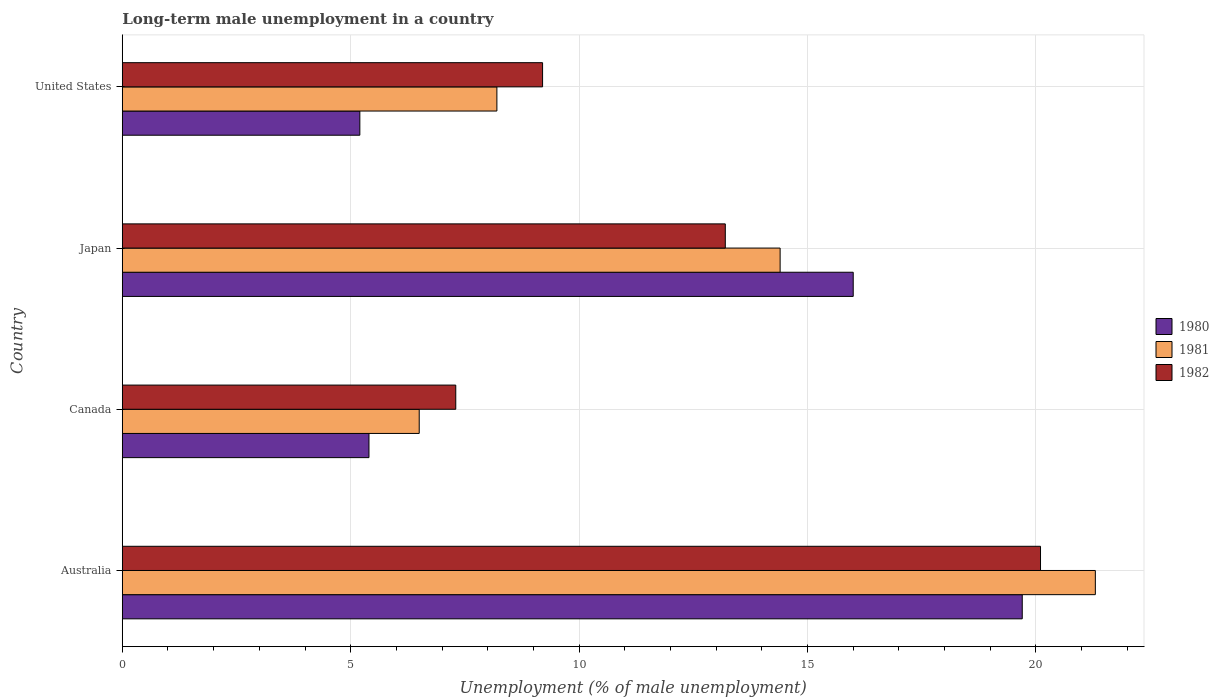How many bars are there on the 1st tick from the top?
Ensure brevity in your answer.  3. In how many cases, is the number of bars for a given country not equal to the number of legend labels?
Offer a terse response. 0. What is the percentage of long-term unemployed male population in 1980 in Australia?
Ensure brevity in your answer.  19.7. Across all countries, what is the maximum percentage of long-term unemployed male population in 1982?
Your answer should be compact. 20.1. Across all countries, what is the minimum percentage of long-term unemployed male population in 1982?
Your answer should be compact. 7.3. In which country was the percentage of long-term unemployed male population in 1980 maximum?
Provide a short and direct response. Australia. In which country was the percentage of long-term unemployed male population in 1980 minimum?
Provide a succinct answer. United States. What is the total percentage of long-term unemployed male population in 1981 in the graph?
Provide a short and direct response. 50.4. What is the difference between the percentage of long-term unemployed male population in 1981 in Australia and that in Canada?
Provide a short and direct response. 14.8. What is the difference between the percentage of long-term unemployed male population in 1980 in Japan and the percentage of long-term unemployed male population in 1981 in United States?
Your answer should be compact. 7.8. What is the average percentage of long-term unemployed male population in 1981 per country?
Your answer should be compact. 12.6. What is the difference between the percentage of long-term unemployed male population in 1982 and percentage of long-term unemployed male population in 1980 in Australia?
Offer a terse response. 0.4. In how many countries, is the percentage of long-term unemployed male population in 1982 greater than 16 %?
Your answer should be very brief. 1. What is the ratio of the percentage of long-term unemployed male population in 1981 in Japan to that in United States?
Provide a succinct answer. 1.76. Is the difference between the percentage of long-term unemployed male population in 1982 in Australia and Canada greater than the difference between the percentage of long-term unemployed male population in 1980 in Australia and Canada?
Offer a very short reply. No. What is the difference between the highest and the second highest percentage of long-term unemployed male population in 1981?
Your answer should be compact. 6.9. What is the difference between the highest and the lowest percentage of long-term unemployed male population in 1981?
Your response must be concise. 14.8. How many bars are there?
Give a very brief answer. 12. What is the difference between two consecutive major ticks on the X-axis?
Offer a terse response. 5. Are the values on the major ticks of X-axis written in scientific E-notation?
Your response must be concise. No. Does the graph contain any zero values?
Provide a short and direct response. No. What is the title of the graph?
Provide a succinct answer. Long-term male unemployment in a country. What is the label or title of the X-axis?
Keep it short and to the point. Unemployment (% of male unemployment). What is the label or title of the Y-axis?
Provide a succinct answer. Country. What is the Unemployment (% of male unemployment) in 1980 in Australia?
Provide a succinct answer. 19.7. What is the Unemployment (% of male unemployment) in 1981 in Australia?
Your response must be concise. 21.3. What is the Unemployment (% of male unemployment) of 1982 in Australia?
Make the answer very short. 20.1. What is the Unemployment (% of male unemployment) in 1980 in Canada?
Make the answer very short. 5.4. What is the Unemployment (% of male unemployment) of 1982 in Canada?
Keep it short and to the point. 7.3. What is the Unemployment (% of male unemployment) in 1981 in Japan?
Your answer should be compact. 14.4. What is the Unemployment (% of male unemployment) in 1982 in Japan?
Offer a terse response. 13.2. What is the Unemployment (% of male unemployment) of 1980 in United States?
Your answer should be very brief. 5.2. What is the Unemployment (% of male unemployment) in 1981 in United States?
Your response must be concise. 8.2. What is the Unemployment (% of male unemployment) in 1982 in United States?
Give a very brief answer. 9.2. Across all countries, what is the maximum Unemployment (% of male unemployment) of 1980?
Make the answer very short. 19.7. Across all countries, what is the maximum Unemployment (% of male unemployment) in 1981?
Offer a terse response. 21.3. Across all countries, what is the maximum Unemployment (% of male unemployment) in 1982?
Your response must be concise. 20.1. Across all countries, what is the minimum Unemployment (% of male unemployment) of 1980?
Provide a succinct answer. 5.2. Across all countries, what is the minimum Unemployment (% of male unemployment) of 1982?
Your answer should be very brief. 7.3. What is the total Unemployment (% of male unemployment) in 1980 in the graph?
Make the answer very short. 46.3. What is the total Unemployment (% of male unemployment) in 1981 in the graph?
Provide a succinct answer. 50.4. What is the total Unemployment (% of male unemployment) of 1982 in the graph?
Your answer should be compact. 49.8. What is the difference between the Unemployment (% of male unemployment) in 1980 in Australia and that in Canada?
Provide a short and direct response. 14.3. What is the difference between the Unemployment (% of male unemployment) of 1981 in Australia and that in Canada?
Give a very brief answer. 14.8. What is the difference between the Unemployment (% of male unemployment) in 1980 in Australia and that in Japan?
Offer a very short reply. 3.7. What is the difference between the Unemployment (% of male unemployment) of 1982 in Australia and that in United States?
Provide a short and direct response. 10.9. What is the difference between the Unemployment (% of male unemployment) in 1982 in Canada and that in United States?
Keep it short and to the point. -1.9. What is the difference between the Unemployment (% of male unemployment) in 1980 in Japan and that in United States?
Ensure brevity in your answer.  10.8. What is the difference between the Unemployment (% of male unemployment) in 1981 in Japan and that in United States?
Provide a short and direct response. 6.2. What is the difference between the Unemployment (% of male unemployment) of 1982 in Japan and that in United States?
Your response must be concise. 4. What is the difference between the Unemployment (% of male unemployment) of 1980 in Australia and the Unemployment (% of male unemployment) of 1981 in Canada?
Your answer should be very brief. 13.2. What is the difference between the Unemployment (% of male unemployment) in 1980 in Australia and the Unemployment (% of male unemployment) in 1981 in Japan?
Your answer should be very brief. 5.3. What is the difference between the Unemployment (% of male unemployment) in 1981 in Australia and the Unemployment (% of male unemployment) in 1982 in United States?
Keep it short and to the point. 12.1. What is the difference between the Unemployment (% of male unemployment) in 1980 in Canada and the Unemployment (% of male unemployment) in 1982 in Japan?
Your answer should be compact. -7.8. What is the difference between the Unemployment (% of male unemployment) of 1981 in Canada and the Unemployment (% of male unemployment) of 1982 in Japan?
Your answer should be very brief. -6.7. What is the difference between the Unemployment (% of male unemployment) in 1980 in Japan and the Unemployment (% of male unemployment) in 1981 in United States?
Offer a very short reply. 7.8. What is the average Unemployment (% of male unemployment) of 1980 per country?
Your answer should be compact. 11.57. What is the average Unemployment (% of male unemployment) in 1981 per country?
Your answer should be compact. 12.6. What is the average Unemployment (% of male unemployment) in 1982 per country?
Provide a short and direct response. 12.45. What is the difference between the Unemployment (% of male unemployment) in 1980 and Unemployment (% of male unemployment) in 1981 in Australia?
Give a very brief answer. -1.6. What is the difference between the Unemployment (% of male unemployment) of 1980 and Unemployment (% of male unemployment) of 1982 in Australia?
Your response must be concise. -0.4. What is the difference between the Unemployment (% of male unemployment) in 1980 and Unemployment (% of male unemployment) in 1982 in Canada?
Offer a very short reply. -1.9. What is the difference between the Unemployment (% of male unemployment) of 1980 and Unemployment (% of male unemployment) of 1982 in Japan?
Keep it short and to the point. 2.8. What is the difference between the Unemployment (% of male unemployment) of 1981 and Unemployment (% of male unemployment) of 1982 in Japan?
Provide a short and direct response. 1.2. What is the difference between the Unemployment (% of male unemployment) in 1980 and Unemployment (% of male unemployment) in 1981 in United States?
Give a very brief answer. -3. What is the difference between the Unemployment (% of male unemployment) in 1981 and Unemployment (% of male unemployment) in 1982 in United States?
Keep it short and to the point. -1. What is the ratio of the Unemployment (% of male unemployment) in 1980 in Australia to that in Canada?
Offer a terse response. 3.65. What is the ratio of the Unemployment (% of male unemployment) of 1981 in Australia to that in Canada?
Offer a terse response. 3.28. What is the ratio of the Unemployment (% of male unemployment) of 1982 in Australia to that in Canada?
Your response must be concise. 2.75. What is the ratio of the Unemployment (% of male unemployment) of 1980 in Australia to that in Japan?
Offer a terse response. 1.23. What is the ratio of the Unemployment (% of male unemployment) in 1981 in Australia to that in Japan?
Your answer should be very brief. 1.48. What is the ratio of the Unemployment (% of male unemployment) of 1982 in Australia to that in Japan?
Keep it short and to the point. 1.52. What is the ratio of the Unemployment (% of male unemployment) in 1980 in Australia to that in United States?
Keep it short and to the point. 3.79. What is the ratio of the Unemployment (% of male unemployment) in 1981 in Australia to that in United States?
Your answer should be compact. 2.6. What is the ratio of the Unemployment (% of male unemployment) in 1982 in Australia to that in United States?
Your response must be concise. 2.18. What is the ratio of the Unemployment (% of male unemployment) in 1980 in Canada to that in Japan?
Ensure brevity in your answer.  0.34. What is the ratio of the Unemployment (% of male unemployment) of 1981 in Canada to that in Japan?
Your answer should be compact. 0.45. What is the ratio of the Unemployment (% of male unemployment) in 1982 in Canada to that in Japan?
Your answer should be very brief. 0.55. What is the ratio of the Unemployment (% of male unemployment) of 1980 in Canada to that in United States?
Provide a succinct answer. 1.04. What is the ratio of the Unemployment (% of male unemployment) of 1981 in Canada to that in United States?
Your response must be concise. 0.79. What is the ratio of the Unemployment (% of male unemployment) in 1982 in Canada to that in United States?
Your answer should be very brief. 0.79. What is the ratio of the Unemployment (% of male unemployment) in 1980 in Japan to that in United States?
Provide a succinct answer. 3.08. What is the ratio of the Unemployment (% of male unemployment) of 1981 in Japan to that in United States?
Your response must be concise. 1.76. What is the ratio of the Unemployment (% of male unemployment) in 1982 in Japan to that in United States?
Your answer should be very brief. 1.43. What is the difference between the highest and the second highest Unemployment (% of male unemployment) of 1981?
Provide a short and direct response. 6.9. What is the difference between the highest and the second highest Unemployment (% of male unemployment) in 1982?
Offer a very short reply. 6.9. What is the difference between the highest and the lowest Unemployment (% of male unemployment) in 1980?
Offer a very short reply. 14.5. What is the difference between the highest and the lowest Unemployment (% of male unemployment) of 1981?
Keep it short and to the point. 14.8. What is the difference between the highest and the lowest Unemployment (% of male unemployment) in 1982?
Provide a succinct answer. 12.8. 